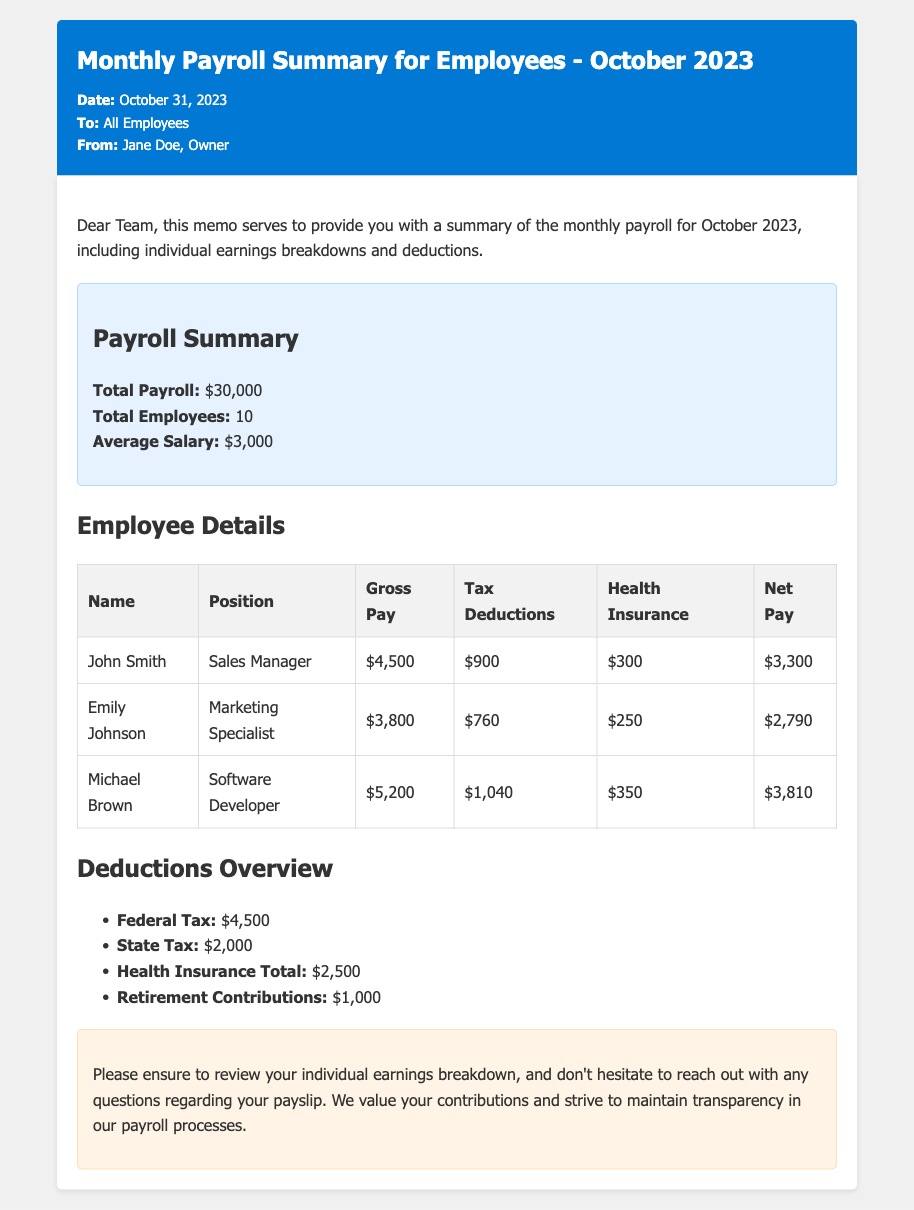What is the date of the memo? The date of the memo is clearly stated in the document as October 31, 2023.
Answer: October 31, 2023 Who is the memo from? The memo indicates the sender as Jane Doe, the Owner of the business.
Answer: Jane Doe How many employees are included in the payroll summary? The total number of employees is listed as 10 in the document.
Answer: 10 What is the gross pay for Michael Brown? The document provides Michael Brown's gross pay as $5,200.
Answer: $5,200 What is the total amount for Federal Tax deductions? The document specifies the total Federal Tax deductions as $4,500.
Answer: $4,500 What is the average salary mentioned in the payroll summary? The average salary is indicated as $3,000 in the summary section of the document.
Answer: $3,000 Which position does Emily Johnson hold? The document states that Emily Johnson is a Marketing Specialist.
Answer: Marketing Specialist What is the total amount deducted for Health Insurance? The total deducted for Health Insurance is presented as $2,500 in the deductions overview.
Answer: $2,500 Why should employees review their individual earnings breakdown? The memo reminds employees to review their earnings to maintain transparency regarding payslips.
Answer: Transparency 